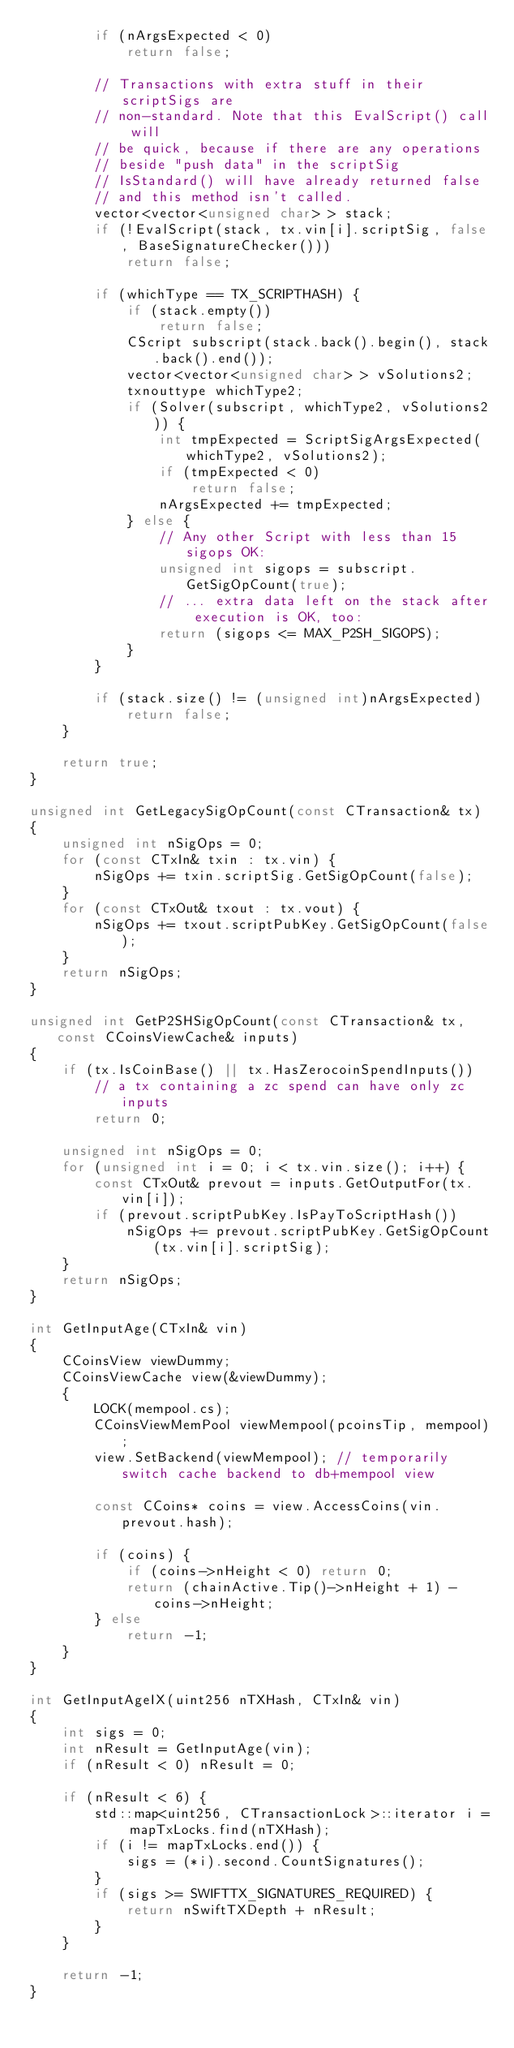Convert code to text. <code><loc_0><loc_0><loc_500><loc_500><_C++_>        if (nArgsExpected < 0)
            return false;

        // Transactions with extra stuff in their scriptSigs are
        // non-standard. Note that this EvalScript() call will
        // be quick, because if there are any operations
        // beside "push data" in the scriptSig
        // IsStandard() will have already returned false
        // and this method isn't called.
        vector<vector<unsigned char> > stack;
        if (!EvalScript(stack, tx.vin[i].scriptSig, false, BaseSignatureChecker()))
            return false;

        if (whichType == TX_SCRIPTHASH) {
            if (stack.empty())
                return false;
            CScript subscript(stack.back().begin(), stack.back().end());
            vector<vector<unsigned char> > vSolutions2;
            txnouttype whichType2;
            if (Solver(subscript, whichType2, vSolutions2)) {
                int tmpExpected = ScriptSigArgsExpected(whichType2, vSolutions2);
                if (tmpExpected < 0)
                    return false;
                nArgsExpected += tmpExpected;
            } else {
                // Any other Script with less than 15 sigops OK:
                unsigned int sigops = subscript.GetSigOpCount(true);
                // ... extra data left on the stack after execution is OK, too:
                return (sigops <= MAX_P2SH_SIGOPS);
            }
        }

        if (stack.size() != (unsigned int)nArgsExpected)
            return false;
    }

    return true;
}

unsigned int GetLegacySigOpCount(const CTransaction& tx)
{
    unsigned int nSigOps = 0;
    for (const CTxIn& txin : tx.vin) {
        nSigOps += txin.scriptSig.GetSigOpCount(false);
    }
    for (const CTxOut& txout : tx.vout) {
        nSigOps += txout.scriptPubKey.GetSigOpCount(false);
    }
    return nSigOps;
}

unsigned int GetP2SHSigOpCount(const CTransaction& tx, const CCoinsViewCache& inputs)
{
    if (tx.IsCoinBase() || tx.HasZerocoinSpendInputs())
        // a tx containing a zc spend can have only zc inputs
        return 0;

    unsigned int nSigOps = 0;
    for (unsigned int i = 0; i < tx.vin.size(); i++) {
        const CTxOut& prevout = inputs.GetOutputFor(tx.vin[i]);
        if (prevout.scriptPubKey.IsPayToScriptHash())
            nSigOps += prevout.scriptPubKey.GetSigOpCount(tx.vin[i].scriptSig);
    }
    return nSigOps;
}

int GetInputAge(CTxIn& vin)
{
    CCoinsView viewDummy;
    CCoinsViewCache view(&viewDummy);
    {
        LOCK(mempool.cs);
        CCoinsViewMemPool viewMempool(pcoinsTip, mempool);
        view.SetBackend(viewMempool); // temporarily switch cache backend to db+mempool view

        const CCoins* coins = view.AccessCoins(vin.prevout.hash);

        if (coins) {
            if (coins->nHeight < 0) return 0;
            return (chainActive.Tip()->nHeight + 1) - coins->nHeight;
        } else
            return -1;
    }
}

int GetInputAgeIX(uint256 nTXHash, CTxIn& vin)
{
    int sigs = 0;
    int nResult = GetInputAge(vin);
    if (nResult < 0) nResult = 0;

    if (nResult < 6) {
        std::map<uint256, CTransactionLock>::iterator i = mapTxLocks.find(nTXHash);
        if (i != mapTxLocks.end()) {
            sigs = (*i).second.CountSignatures();
        }
        if (sigs >= SWIFTTX_SIGNATURES_REQUIRED) {
            return nSwiftTXDepth + nResult;
        }
    }

    return -1;
}
</code> 